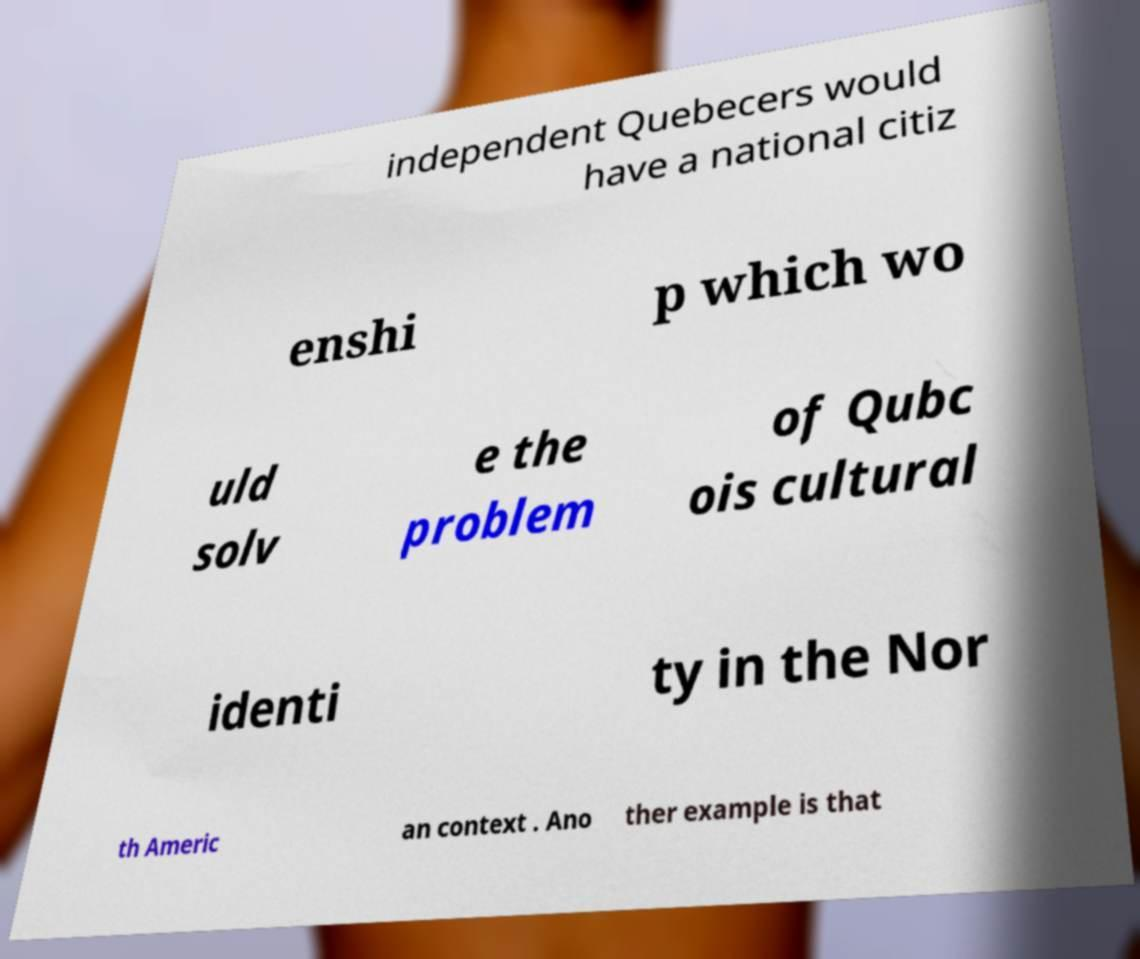Please read and relay the text visible in this image. What does it say? independent Quebecers would have a national citiz enshi p which wo uld solv e the problem of Qubc ois cultural identi ty in the Nor th Americ an context . Ano ther example is that 